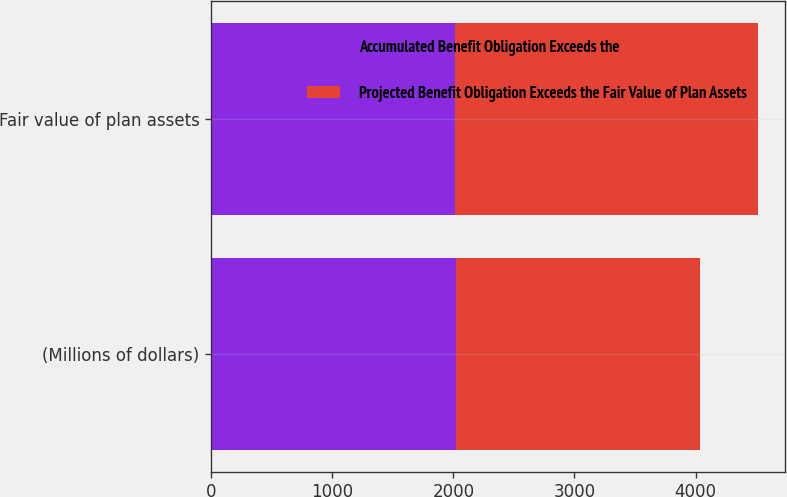<chart> <loc_0><loc_0><loc_500><loc_500><stacked_bar_chart><ecel><fcel>(Millions of dollars)<fcel>Fair value of plan assets<nl><fcel>Accumulated Benefit Obligation Exceeds the<fcel>2018<fcel>2012<nl><fcel>Projected Benefit Obligation Exceeds the Fair Value of Plan Assets<fcel>2018<fcel>2502<nl></chart> 